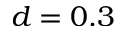Convert formula to latex. <formula><loc_0><loc_0><loc_500><loc_500>d = 0 . 3</formula> 